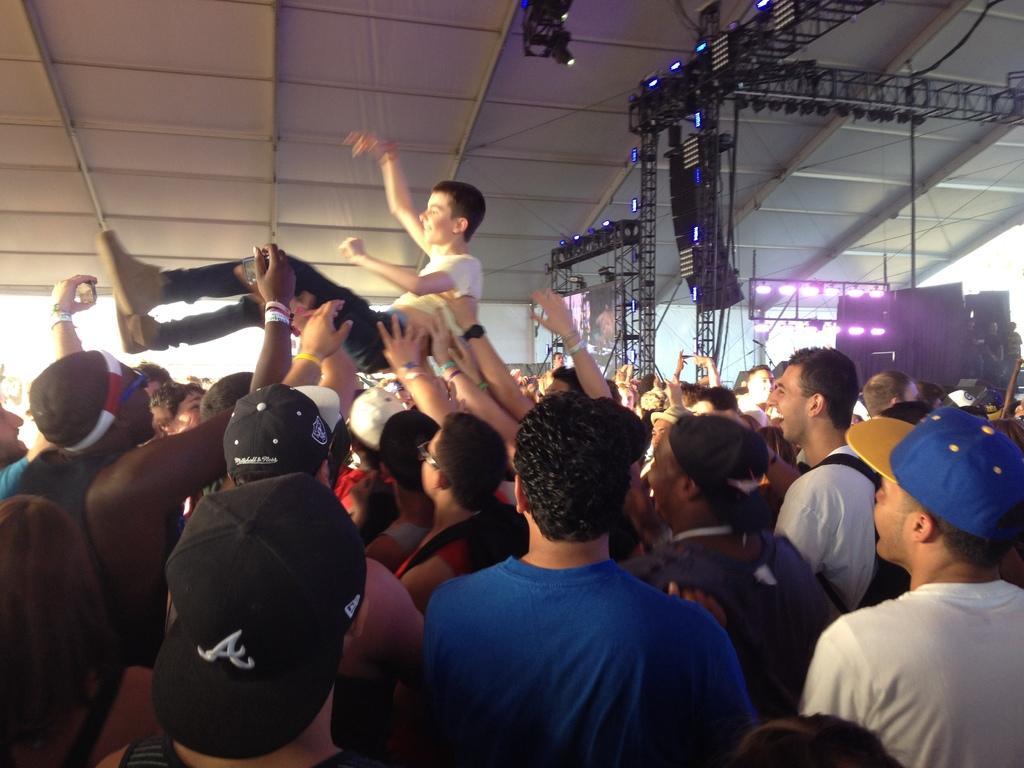How many people are present in the image? There are people in the image, but the exact number is not specified. What are some people doing in the image? Some people are carrying another person in the image. What objects can be seen in the image? There are poles, lights, speakers, and a tent in the image. What accessories are some people wearing? Some people are wearing caps in the image. What type of joke is being told near the basin in the image? There is no basin or joke present in the image. How much salt is being used in the image? There is no salt present in the image. 